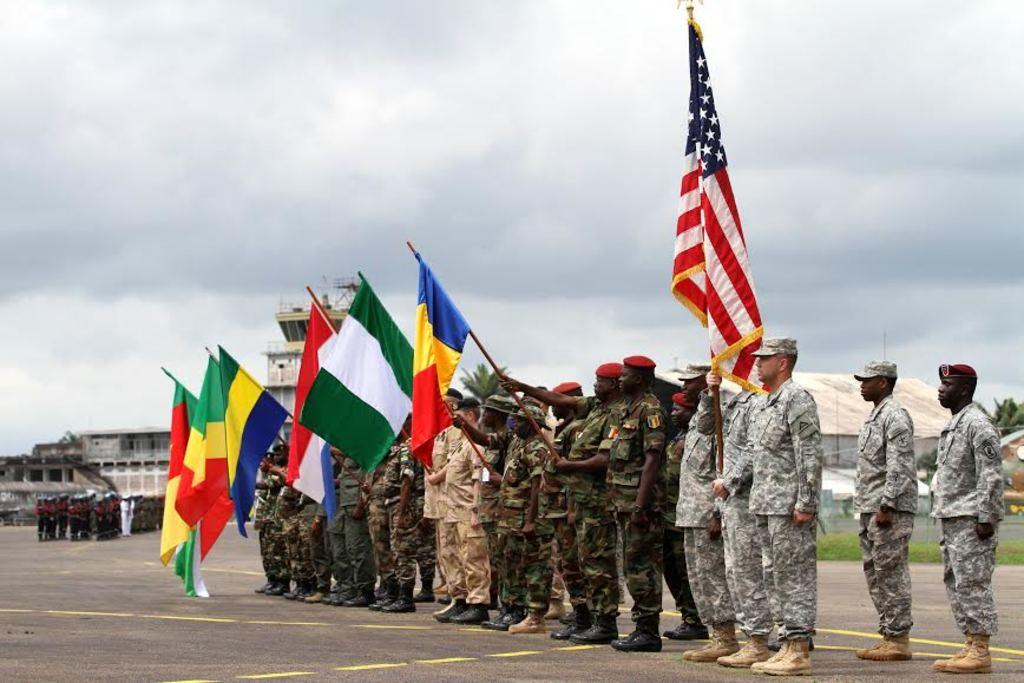What are the people in the image doing? The people in the image are standing on a road. What are some of the people holding in their hands? Some people are holding flags in their hands. Can you describe the background of the image? In the background, there are people, buildings, trees, and the sky visible. What type of volleyball game is being played in the image? There is no volleyball game present in the image. What instrument is being played by the people in the image? There is no instrument being played by the people in the image. 